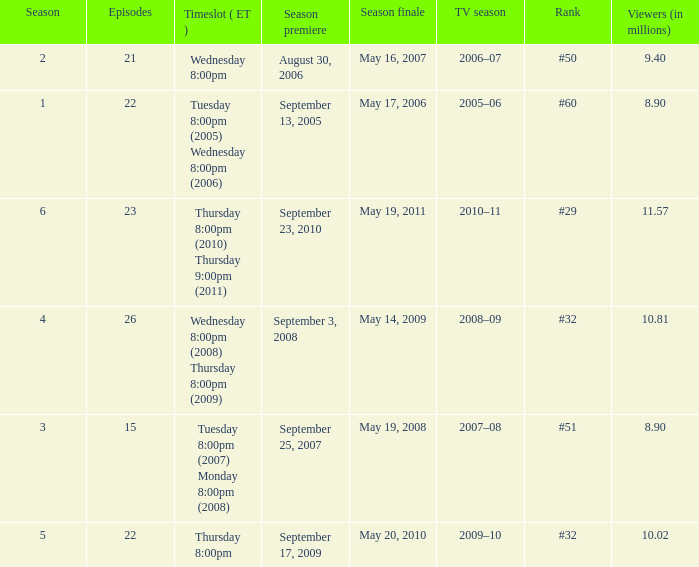How many seasons was the rank equal to #50? 1.0. 